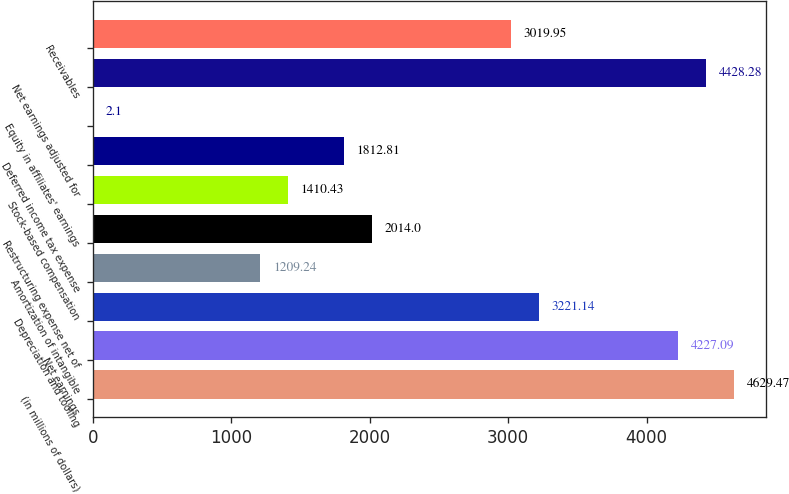Convert chart to OTSL. <chart><loc_0><loc_0><loc_500><loc_500><bar_chart><fcel>(in millions of dollars)<fcel>Net earnings<fcel>Depreciation and tooling<fcel>Amortization of intangible<fcel>Restructuring expense net of<fcel>Stock-based compensation<fcel>Deferred income tax expense<fcel>Equity in affiliates' earnings<fcel>Net earnings adjusted for<fcel>Receivables<nl><fcel>4629.47<fcel>4227.09<fcel>3221.14<fcel>1209.24<fcel>2014<fcel>1410.43<fcel>1812.81<fcel>2.1<fcel>4428.28<fcel>3019.95<nl></chart> 